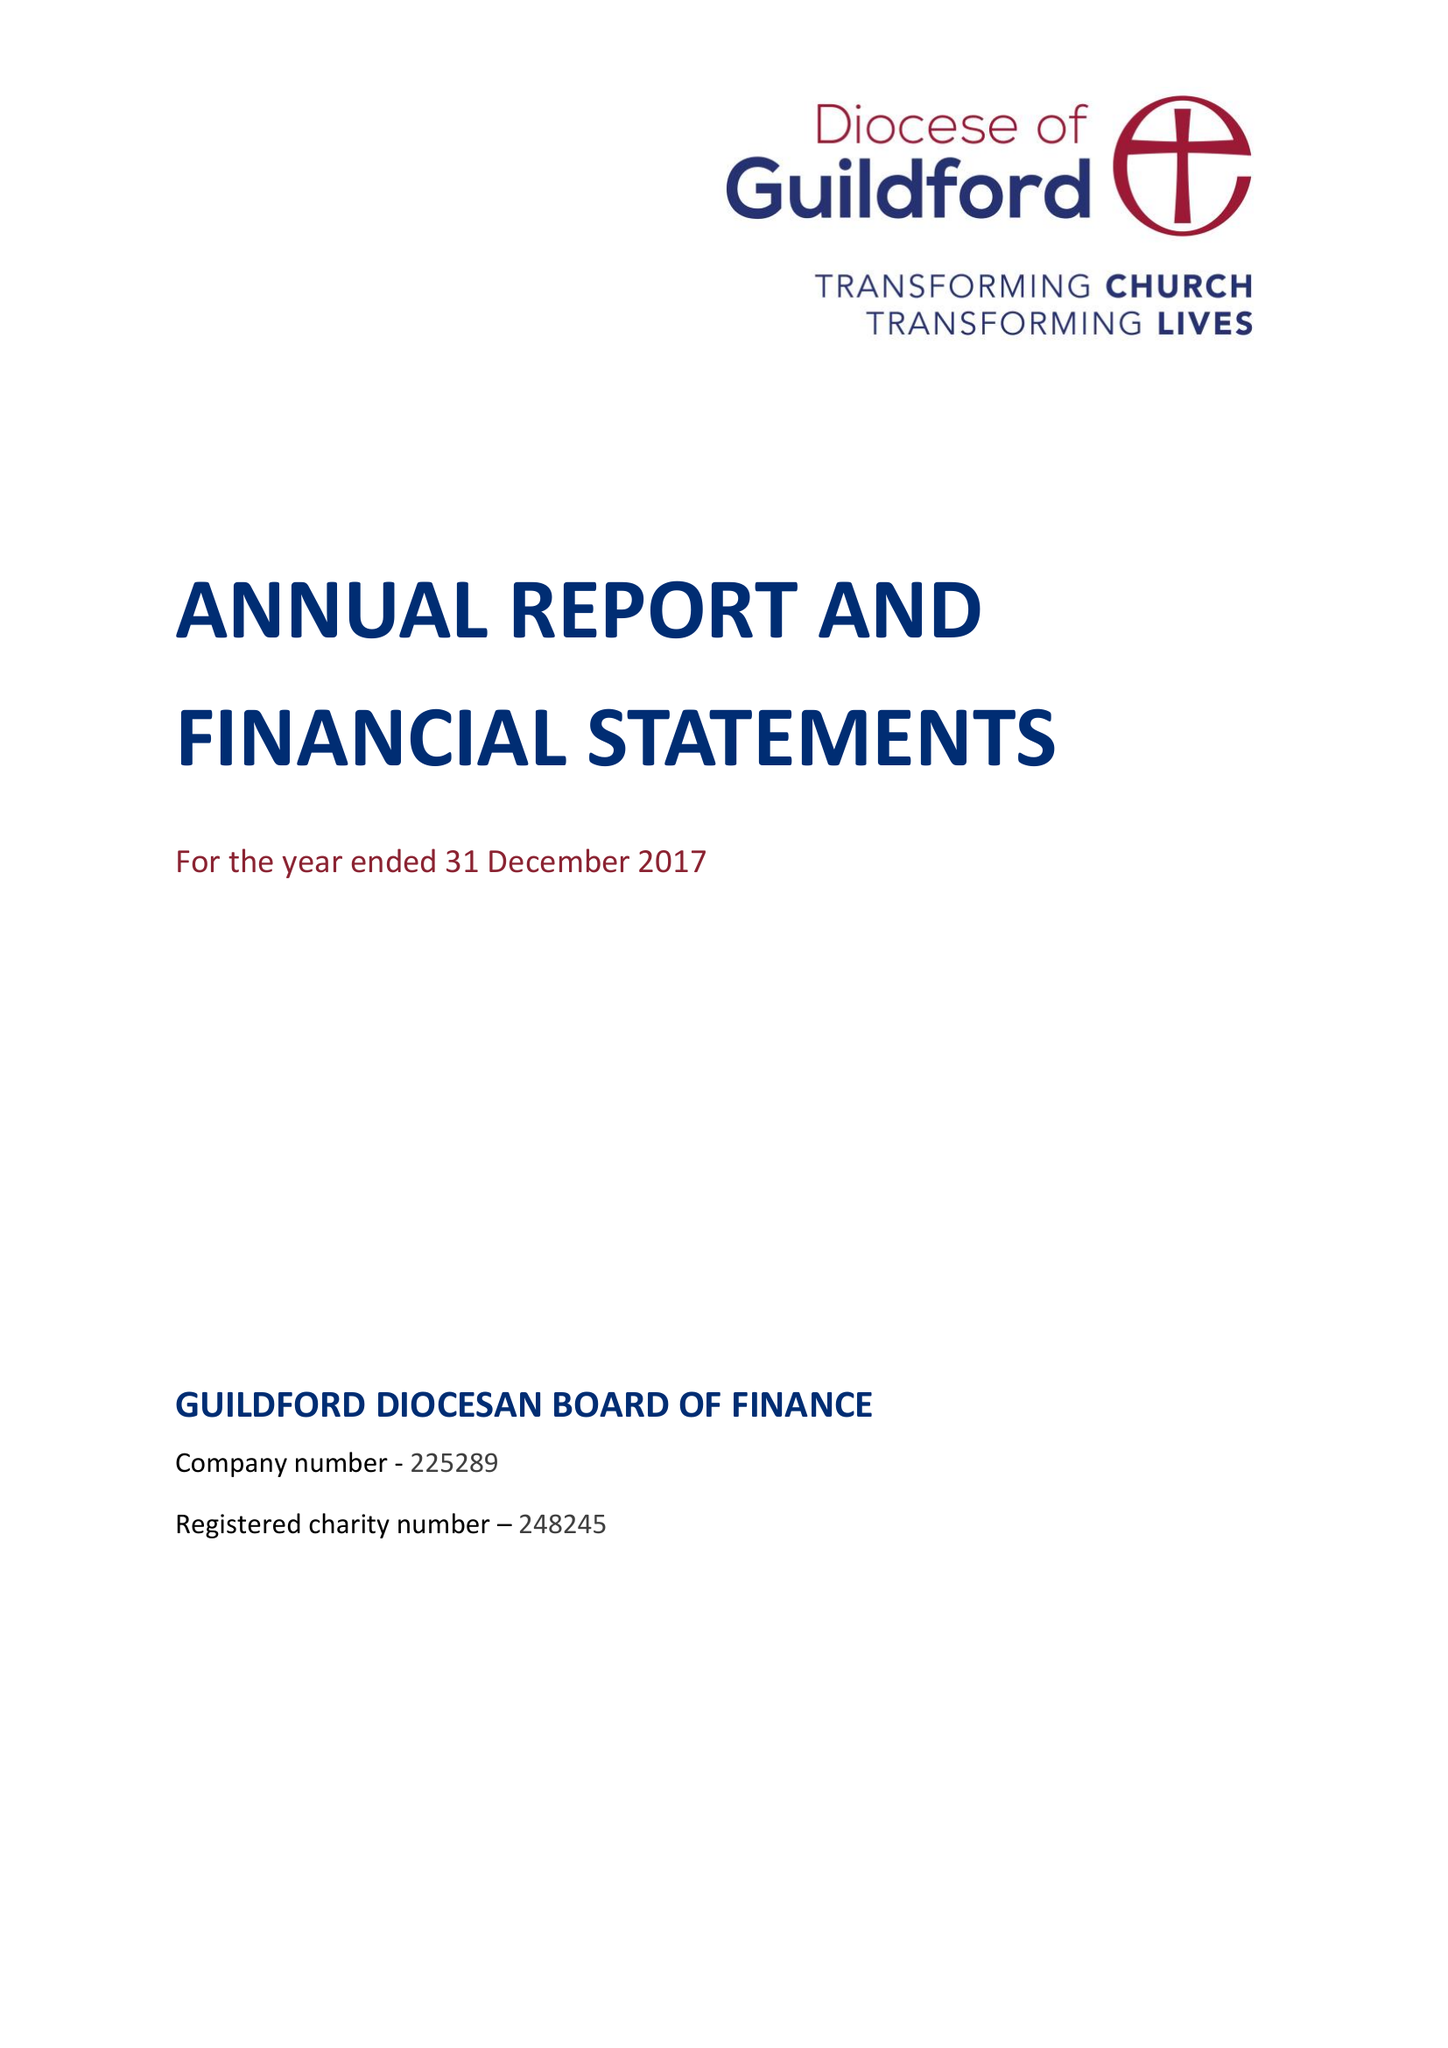What is the value for the address__post_town?
Answer the question using a single word or phrase. GUILDFORD 